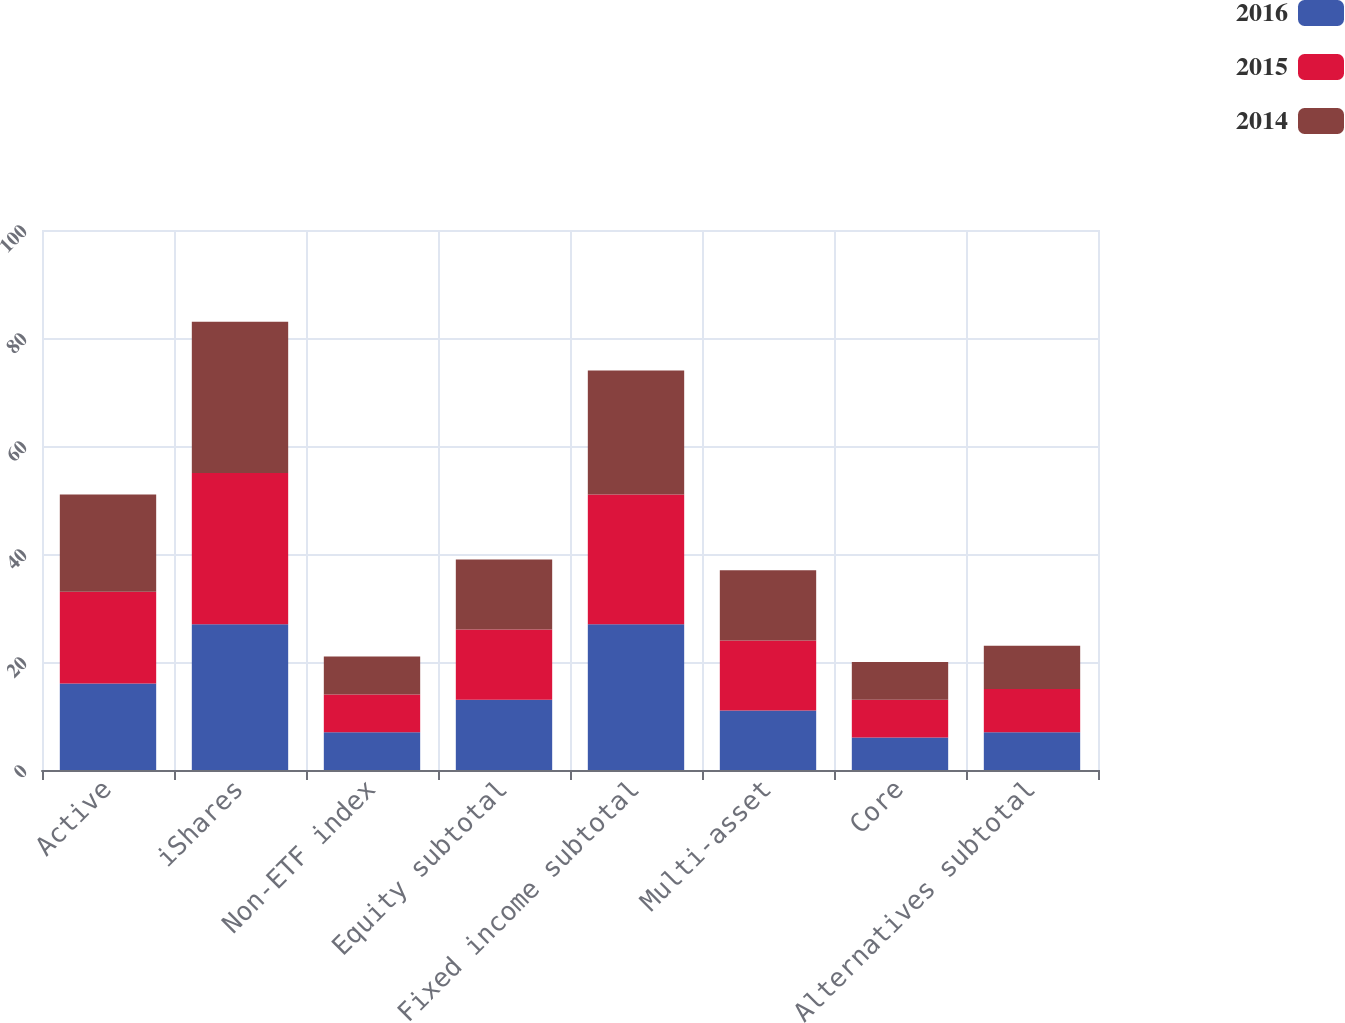<chart> <loc_0><loc_0><loc_500><loc_500><stacked_bar_chart><ecel><fcel>Active<fcel>iShares<fcel>Non-ETF index<fcel>Equity subtotal<fcel>Fixed income subtotal<fcel>Multi-asset<fcel>Core<fcel>Alternatives subtotal<nl><fcel>2016<fcel>16<fcel>27<fcel>7<fcel>13<fcel>27<fcel>11<fcel>6<fcel>7<nl><fcel>2015<fcel>17<fcel>28<fcel>7<fcel>13<fcel>24<fcel>13<fcel>7<fcel>8<nl><fcel>2014<fcel>18<fcel>28<fcel>7<fcel>13<fcel>23<fcel>13<fcel>7<fcel>8<nl></chart> 